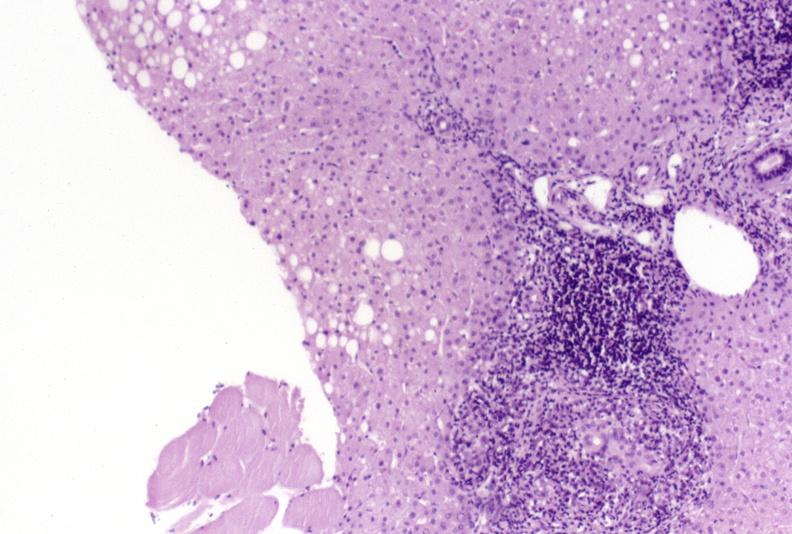s heart present?
Answer the question using a single word or phrase. No 